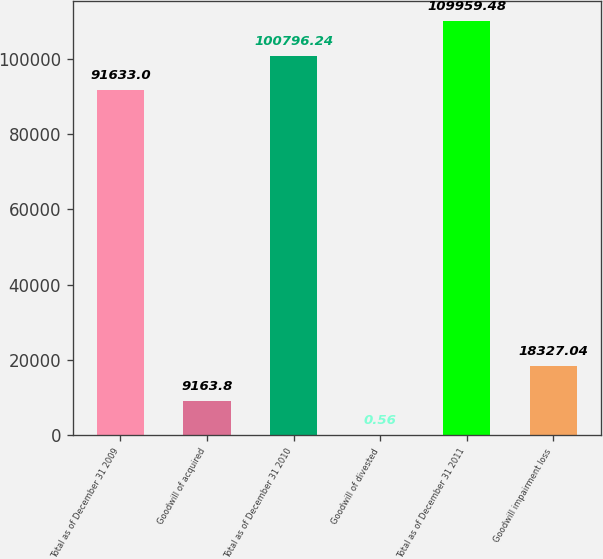Convert chart to OTSL. <chart><loc_0><loc_0><loc_500><loc_500><bar_chart><fcel>Total as of December 31 2009<fcel>Goodwill of acquired<fcel>Total as of December 31 2010<fcel>Goodwill of divested<fcel>Total as of December 31 2011<fcel>Goodwill impairment loss<nl><fcel>91633<fcel>9163.8<fcel>100796<fcel>0.56<fcel>109959<fcel>18327<nl></chart> 